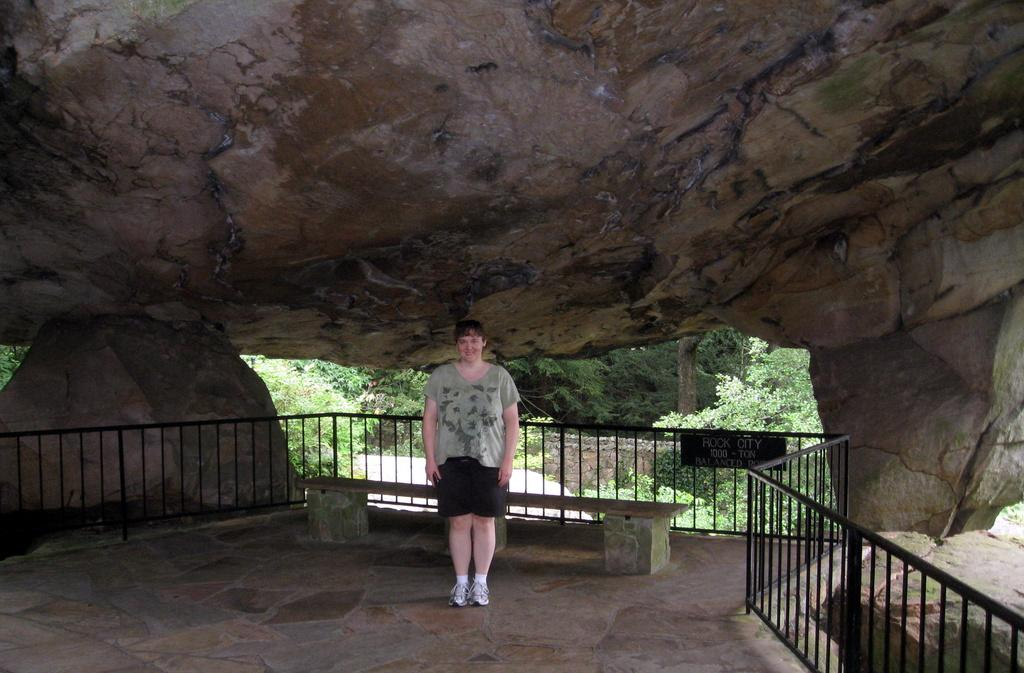What is one of the natural elements present in the image? There are trees in the image. What type of structure can be seen in the image? There is a bench in the image. What material is the fence made of in the image? The fence in the image is made of metal. Can you describe the woman's position in the image? There is a woman standing in the image. What is the main geological feature in the image? There is a rock in the image. What grade of metal is used to make the woman's finger in the image? There is no mention of a woman's finger in the image, and therefore no grade of metal can be determined. 